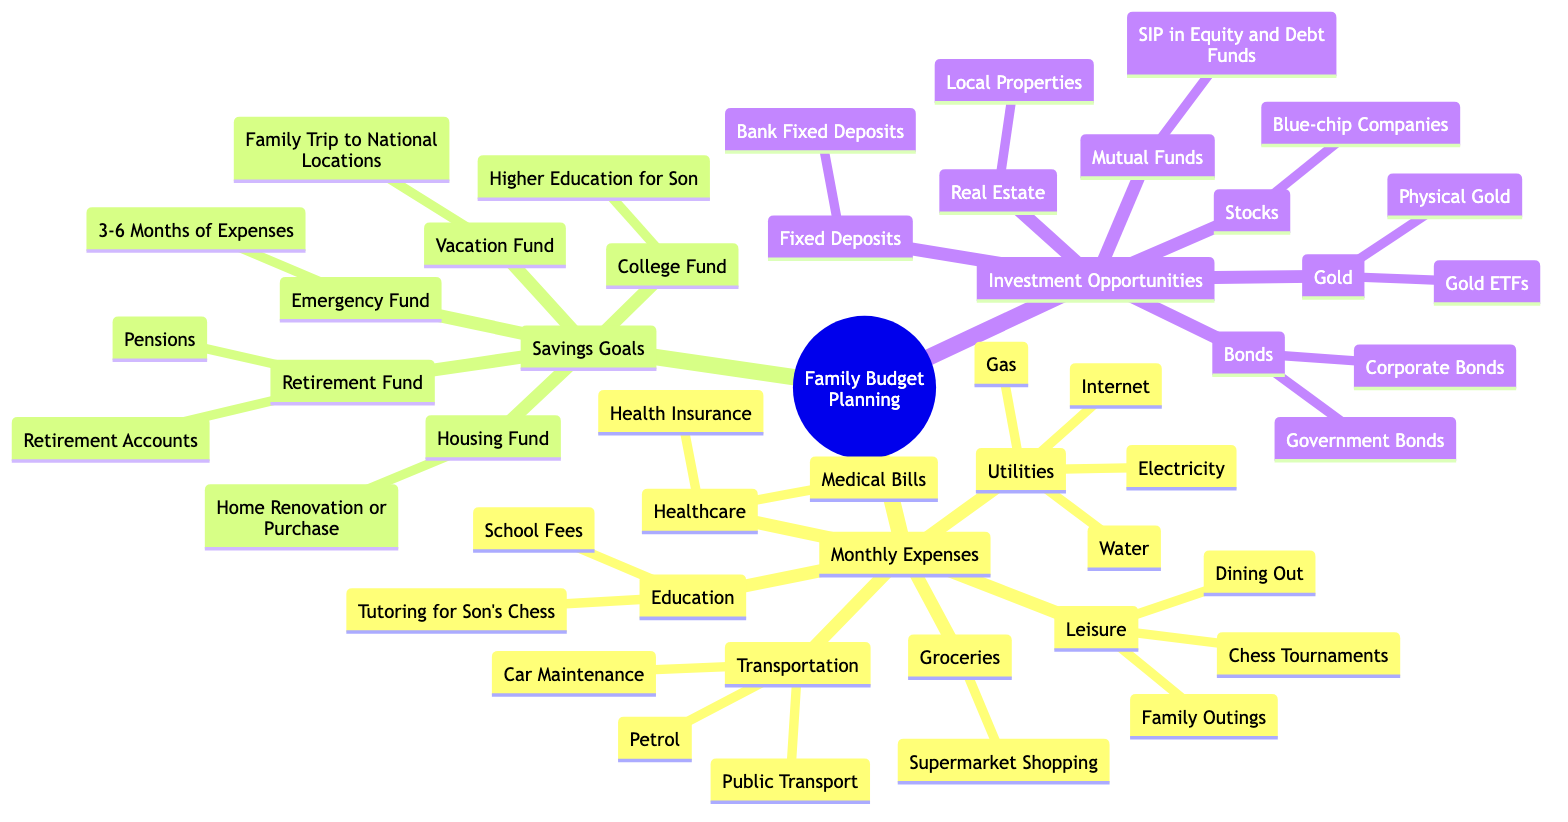What are the main categories in the Family Budget Planning diagram? The main categories can be found as the first-level nodes branching from "Family Budget Planning". They include "Monthly Expenses", "Savings Goals", and "Investment Opportunities".
Answer: Monthly Expenses, Savings Goals, Investment Opportunities How many types of Savings Goals are listed? In the "Savings Goals" category, there are five subcategories: "Emergency Fund", "College Fund", "Vacation Fund", "Housing Fund", and "Retirement Fund". To find this, we count the number of nodes directly connected to "Savings Goals".
Answer: 5 What specific expense is noted under the Education category? The "Education" category includes two specific expenses: "School Fees" and "Tutoring for Son's Chess". The question is looking for one of these two expenses. Both nodes are listed under "Education".
Answer: Tutoring for Son's Chess Which investment opportunity involves local properties? Within the "Investment Opportunities" category, "Real Estate" is the branch that mentions investing in "Local Properties". This information is located directly under the "Real Estate" node.
Answer: Local Properties What is the purpose of the Emergency Fund? The "Emergency Fund" is outlined under "Savings Goals" as being aimed to cover "3-6 Months of Expenses". This is found directly under the "Emergency Fund" node.
Answer: 3-6 Months of Expenses How many types of investments are there in total? The "Investment Opportunities" section has five categories: "Stocks", "Mutual Funds", "Fixed Deposits", "Real Estate", "Bonds", and "Gold". We count each of these categories to find the total count of investment types.
Answer: 6 What kind of leisure activities are mentioned? The "Leisure" category includes three activities: "Family Outings", "Dining Out", and "Chess Tournaments". This information is obtained by looking at the subcategories listed under the "Leisure" node.
Answer: Family Outings, Dining Out, Chess Tournaments Which savings goal is focused on education expenses? The "College Fund" specifically addresses "Higher Education for Son". This information can be found directly attached to the "College Fund" node under "Savings Goals".
Answer: Higher Education for Son 